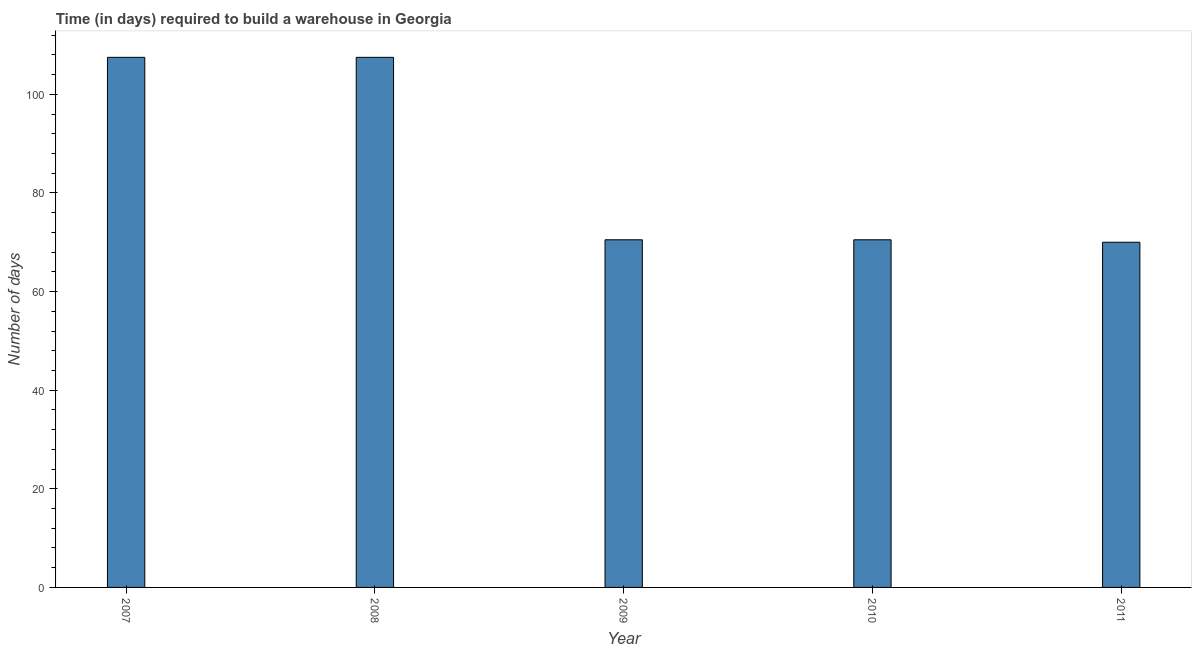Does the graph contain any zero values?
Offer a very short reply. No. Does the graph contain grids?
Your answer should be very brief. No. What is the title of the graph?
Give a very brief answer. Time (in days) required to build a warehouse in Georgia. What is the label or title of the Y-axis?
Your answer should be compact. Number of days. What is the time required to build a warehouse in 2009?
Your answer should be very brief. 70.5. Across all years, what is the maximum time required to build a warehouse?
Provide a succinct answer. 107.5. Across all years, what is the minimum time required to build a warehouse?
Offer a terse response. 70. What is the sum of the time required to build a warehouse?
Give a very brief answer. 426. What is the average time required to build a warehouse per year?
Provide a succinct answer. 85.2. What is the median time required to build a warehouse?
Provide a short and direct response. 70.5. In how many years, is the time required to build a warehouse greater than 56 days?
Give a very brief answer. 5. Do a majority of the years between 2008 and 2011 (inclusive) have time required to build a warehouse greater than 12 days?
Your answer should be compact. Yes. What is the ratio of the time required to build a warehouse in 2008 to that in 2009?
Ensure brevity in your answer.  1.52. Is the sum of the time required to build a warehouse in 2009 and 2011 greater than the maximum time required to build a warehouse across all years?
Your response must be concise. Yes. What is the difference between the highest and the lowest time required to build a warehouse?
Provide a succinct answer. 37.5. In how many years, is the time required to build a warehouse greater than the average time required to build a warehouse taken over all years?
Give a very brief answer. 2. How many bars are there?
Your answer should be very brief. 5. Are all the bars in the graph horizontal?
Ensure brevity in your answer.  No. What is the difference between two consecutive major ticks on the Y-axis?
Make the answer very short. 20. What is the Number of days of 2007?
Offer a very short reply. 107.5. What is the Number of days of 2008?
Keep it short and to the point. 107.5. What is the Number of days of 2009?
Ensure brevity in your answer.  70.5. What is the Number of days in 2010?
Keep it short and to the point. 70.5. What is the Number of days in 2011?
Provide a succinct answer. 70. What is the difference between the Number of days in 2007 and 2010?
Provide a succinct answer. 37. What is the difference between the Number of days in 2007 and 2011?
Your answer should be very brief. 37.5. What is the difference between the Number of days in 2008 and 2011?
Your answer should be very brief. 37.5. What is the difference between the Number of days in 2009 and 2010?
Provide a succinct answer. 0. What is the difference between the Number of days in 2009 and 2011?
Ensure brevity in your answer.  0.5. What is the ratio of the Number of days in 2007 to that in 2008?
Your response must be concise. 1. What is the ratio of the Number of days in 2007 to that in 2009?
Keep it short and to the point. 1.52. What is the ratio of the Number of days in 2007 to that in 2010?
Make the answer very short. 1.52. What is the ratio of the Number of days in 2007 to that in 2011?
Offer a terse response. 1.54. What is the ratio of the Number of days in 2008 to that in 2009?
Offer a very short reply. 1.52. What is the ratio of the Number of days in 2008 to that in 2010?
Provide a short and direct response. 1.52. What is the ratio of the Number of days in 2008 to that in 2011?
Your answer should be compact. 1.54. What is the ratio of the Number of days in 2009 to that in 2011?
Your answer should be compact. 1.01. What is the ratio of the Number of days in 2010 to that in 2011?
Keep it short and to the point. 1.01. 